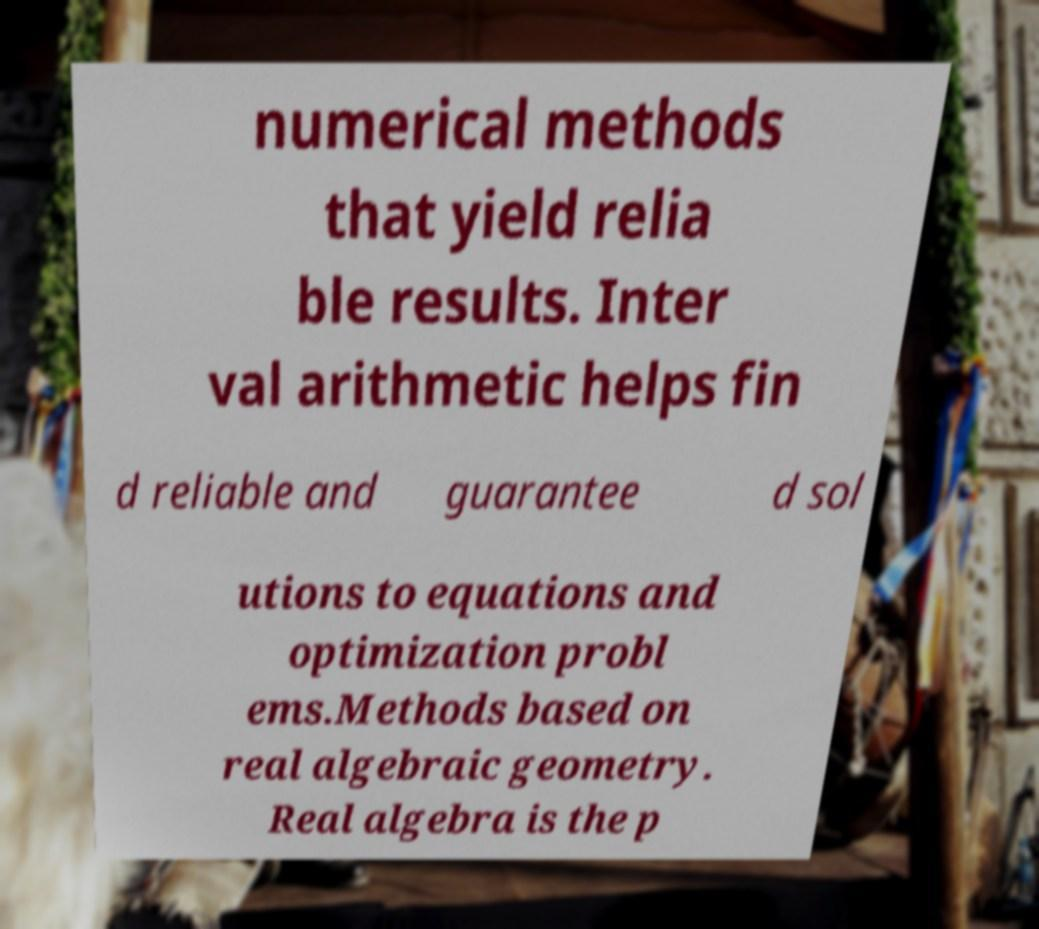Can you accurately transcribe the text from the provided image for me? numerical methods that yield relia ble results. Inter val arithmetic helps fin d reliable and guarantee d sol utions to equations and optimization probl ems.Methods based on real algebraic geometry. Real algebra is the p 